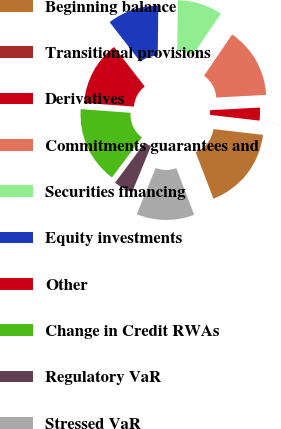Convert chart to OTSL. <chart><loc_0><loc_0><loc_500><loc_500><pie_chart><fcel>Beginning balance<fcel>Transitional provisions<fcel>Derivatives<fcel>Commitments guarantees and<fcel>Securities financing<fcel>Equity investments<fcel>Other<fcel>Change in Credit RWAs<fcel>Regulatory VaR<fcel>Stressed VaR<nl><fcel>17.33%<fcel>0.01%<fcel>2.67%<fcel>14.66%<fcel>9.33%<fcel>10.67%<fcel>13.33%<fcel>16.0%<fcel>4.0%<fcel>12.0%<nl></chart> 